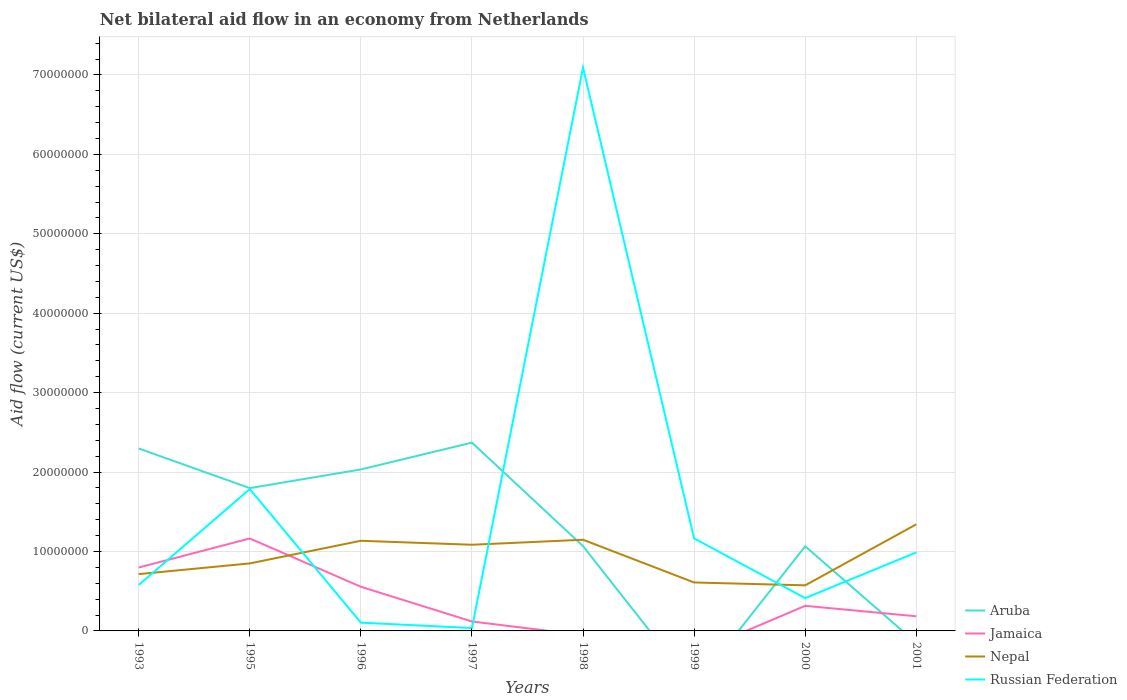What is the total net bilateral aid flow in Nepal in the graph?
Make the answer very short. 3.60e+05. What is the difference between the highest and the second highest net bilateral aid flow in Jamaica?
Your answer should be compact. 1.16e+07. What is the difference between the highest and the lowest net bilateral aid flow in Nepal?
Your response must be concise. 4. How many years are there in the graph?
Provide a succinct answer. 8. What is the difference between two consecutive major ticks on the Y-axis?
Your response must be concise. 1.00e+07. Are the values on the major ticks of Y-axis written in scientific E-notation?
Ensure brevity in your answer.  No. How are the legend labels stacked?
Your answer should be compact. Vertical. What is the title of the graph?
Offer a very short reply. Net bilateral aid flow in an economy from Netherlands. Does "Congo (Republic)" appear as one of the legend labels in the graph?
Offer a terse response. No. What is the Aid flow (current US$) in Aruba in 1993?
Offer a very short reply. 2.30e+07. What is the Aid flow (current US$) of Jamaica in 1993?
Make the answer very short. 7.98e+06. What is the Aid flow (current US$) in Nepal in 1993?
Offer a very short reply. 7.15e+06. What is the Aid flow (current US$) in Russian Federation in 1993?
Your answer should be compact. 5.78e+06. What is the Aid flow (current US$) in Aruba in 1995?
Provide a succinct answer. 1.80e+07. What is the Aid flow (current US$) of Jamaica in 1995?
Provide a succinct answer. 1.16e+07. What is the Aid flow (current US$) in Nepal in 1995?
Make the answer very short. 8.50e+06. What is the Aid flow (current US$) in Russian Federation in 1995?
Your answer should be very brief. 1.79e+07. What is the Aid flow (current US$) of Aruba in 1996?
Offer a very short reply. 2.03e+07. What is the Aid flow (current US$) in Jamaica in 1996?
Make the answer very short. 5.56e+06. What is the Aid flow (current US$) of Nepal in 1996?
Your answer should be compact. 1.14e+07. What is the Aid flow (current US$) of Russian Federation in 1996?
Keep it short and to the point. 1.04e+06. What is the Aid flow (current US$) of Aruba in 1997?
Your response must be concise. 2.37e+07. What is the Aid flow (current US$) in Jamaica in 1997?
Provide a succinct answer. 1.19e+06. What is the Aid flow (current US$) of Nepal in 1997?
Provide a succinct answer. 1.08e+07. What is the Aid flow (current US$) in Russian Federation in 1997?
Make the answer very short. 3.60e+05. What is the Aid flow (current US$) of Aruba in 1998?
Your answer should be compact. 1.07e+07. What is the Aid flow (current US$) of Jamaica in 1998?
Offer a very short reply. 0. What is the Aid flow (current US$) of Nepal in 1998?
Offer a very short reply. 1.15e+07. What is the Aid flow (current US$) of Russian Federation in 1998?
Offer a terse response. 7.09e+07. What is the Aid flow (current US$) of Aruba in 1999?
Your answer should be very brief. 0. What is the Aid flow (current US$) in Jamaica in 1999?
Make the answer very short. 0. What is the Aid flow (current US$) of Nepal in 1999?
Give a very brief answer. 6.10e+06. What is the Aid flow (current US$) in Russian Federation in 1999?
Keep it short and to the point. 1.16e+07. What is the Aid flow (current US$) in Aruba in 2000?
Your answer should be compact. 1.07e+07. What is the Aid flow (current US$) in Jamaica in 2000?
Offer a very short reply. 3.16e+06. What is the Aid flow (current US$) of Nepal in 2000?
Provide a succinct answer. 5.74e+06. What is the Aid flow (current US$) in Russian Federation in 2000?
Provide a succinct answer. 4.13e+06. What is the Aid flow (current US$) of Aruba in 2001?
Give a very brief answer. 0. What is the Aid flow (current US$) in Jamaica in 2001?
Your answer should be very brief. 1.84e+06. What is the Aid flow (current US$) of Nepal in 2001?
Keep it short and to the point. 1.34e+07. What is the Aid flow (current US$) of Russian Federation in 2001?
Your answer should be very brief. 9.88e+06. Across all years, what is the maximum Aid flow (current US$) of Aruba?
Provide a succinct answer. 2.37e+07. Across all years, what is the maximum Aid flow (current US$) in Jamaica?
Keep it short and to the point. 1.16e+07. Across all years, what is the maximum Aid flow (current US$) of Nepal?
Your answer should be compact. 1.34e+07. Across all years, what is the maximum Aid flow (current US$) in Russian Federation?
Your answer should be compact. 7.09e+07. Across all years, what is the minimum Aid flow (current US$) in Jamaica?
Make the answer very short. 0. Across all years, what is the minimum Aid flow (current US$) of Nepal?
Ensure brevity in your answer.  5.74e+06. Across all years, what is the minimum Aid flow (current US$) in Russian Federation?
Make the answer very short. 3.60e+05. What is the total Aid flow (current US$) in Aruba in the graph?
Your response must be concise. 1.06e+08. What is the total Aid flow (current US$) of Jamaica in the graph?
Make the answer very short. 3.14e+07. What is the total Aid flow (current US$) of Nepal in the graph?
Offer a terse response. 7.46e+07. What is the total Aid flow (current US$) in Russian Federation in the graph?
Give a very brief answer. 1.22e+08. What is the difference between the Aid flow (current US$) in Aruba in 1993 and that in 1995?
Your response must be concise. 4.99e+06. What is the difference between the Aid flow (current US$) of Jamaica in 1993 and that in 1995?
Offer a very short reply. -3.66e+06. What is the difference between the Aid flow (current US$) in Nepal in 1993 and that in 1995?
Your response must be concise. -1.35e+06. What is the difference between the Aid flow (current US$) of Russian Federation in 1993 and that in 1995?
Provide a succinct answer. -1.21e+07. What is the difference between the Aid flow (current US$) in Aruba in 1993 and that in 1996?
Your response must be concise. 2.64e+06. What is the difference between the Aid flow (current US$) in Jamaica in 1993 and that in 1996?
Ensure brevity in your answer.  2.42e+06. What is the difference between the Aid flow (current US$) of Nepal in 1993 and that in 1996?
Keep it short and to the point. -4.20e+06. What is the difference between the Aid flow (current US$) in Russian Federation in 1993 and that in 1996?
Your answer should be compact. 4.74e+06. What is the difference between the Aid flow (current US$) in Aruba in 1993 and that in 1997?
Offer a very short reply. -7.40e+05. What is the difference between the Aid flow (current US$) in Jamaica in 1993 and that in 1997?
Provide a short and direct response. 6.79e+06. What is the difference between the Aid flow (current US$) of Nepal in 1993 and that in 1997?
Provide a short and direct response. -3.70e+06. What is the difference between the Aid flow (current US$) of Russian Federation in 1993 and that in 1997?
Offer a terse response. 5.42e+06. What is the difference between the Aid flow (current US$) in Aruba in 1993 and that in 1998?
Ensure brevity in your answer.  1.23e+07. What is the difference between the Aid flow (current US$) of Nepal in 1993 and that in 1998?
Keep it short and to the point. -4.33e+06. What is the difference between the Aid flow (current US$) in Russian Federation in 1993 and that in 1998?
Offer a terse response. -6.52e+07. What is the difference between the Aid flow (current US$) of Nepal in 1993 and that in 1999?
Your answer should be very brief. 1.05e+06. What is the difference between the Aid flow (current US$) in Russian Federation in 1993 and that in 1999?
Ensure brevity in your answer.  -5.87e+06. What is the difference between the Aid flow (current US$) in Aruba in 1993 and that in 2000?
Ensure brevity in your answer.  1.23e+07. What is the difference between the Aid flow (current US$) in Jamaica in 1993 and that in 2000?
Provide a short and direct response. 4.82e+06. What is the difference between the Aid flow (current US$) in Nepal in 1993 and that in 2000?
Ensure brevity in your answer.  1.41e+06. What is the difference between the Aid flow (current US$) in Russian Federation in 1993 and that in 2000?
Offer a terse response. 1.65e+06. What is the difference between the Aid flow (current US$) in Jamaica in 1993 and that in 2001?
Your answer should be compact. 6.14e+06. What is the difference between the Aid flow (current US$) in Nepal in 1993 and that in 2001?
Provide a short and direct response. -6.27e+06. What is the difference between the Aid flow (current US$) in Russian Federation in 1993 and that in 2001?
Make the answer very short. -4.10e+06. What is the difference between the Aid flow (current US$) in Aruba in 1995 and that in 1996?
Give a very brief answer. -2.35e+06. What is the difference between the Aid flow (current US$) in Jamaica in 1995 and that in 1996?
Your response must be concise. 6.08e+06. What is the difference between the Aid flow (current US$) of Nepal in 1995 and that in 1996?
Provide a short and direct response. -2.85e+06. What is the difference between the Aid flow (current US$) of Russian Federation in 1995 and that in 1996?
Provide a short and direct response. 1.68e+07. What is the difference between the Aid flow (current US$) in Aruba in 1995 and that in 1997?
Ensure brevity in your answer.  -5.73e+06. What is the difference between the Aid flow (current US$) in Jamaica in 1995 and that in 1997?
Your answer should be compact. 1.04e+07. What is the difference between the Aid flow (current US$) of Nepal in 1995 and that in 1997?
Your response must be concise. -2.35e+06. What is the difference between the Aid flow (current US$) of Russian Federation in 1995 and that in 1997?
Give a very brief answer. 1.75e+07. What is the difference between the Aid flow (current US$) of Aruba in 1995 and that in 1998?
Make the answer very short. 7.30e+06. What is the difference between the Aid flow (current US$) of Nepal in 1995 and that in 1998?
Your answer should be very brief. -2.98e+06. What is the difference between the Aid flow (current US$) in Russian Federation in 1995 and that in 1998?
Keep it short and to the point. -5.31e+07. What is the difference between the Aid flow (current US$) of Nepal in 1995 and that in 1999?
Your answer should be compact. 2.40e+06. What is the difference between the Aid flow (current US$) in Russian Federation in 1995 and that in 1999?
Keep it short and to the point. 6.21e+06. What is the difference between the Aid flow (current US$) of Aruba in 1995 and that in 2000?
Your answer should be compact. 7.32e+06. What is the difference between the Aid flow (current US$) in Jamaica in 1995 and that in 2000?
Ensure brevity in your answer.  8.48e+06. What is the difference between the Aid flow (current US$) in Nepal in 1995 and that in 2000?
Make the answer very short. 2.76e+06. What is the difference between the Aid flow (current US$) of Russian Federation in 1995 and that in 2000?
Provide a short and direct response. 1.37e+07. What is the difference between the Aid flow (current US$) in Jamaica in 1995 and that in 2001?
Ensure brevity in your answer.  9.80e+06. What is the difference between the Aid flow (current US$) in Nepal in 1995 and that in 2001?
Your response must be concise. -4.92e+06. What is the difference between the Aid flow (current US$) in Russian Federation in 1995 and that in 2001?
Your answer should be very brief. 7.98e+06. What is the difference between the Aid flow (current US$) of Aruba in 1996 and that in 1997?
Provide a succinct answer. -3.38e+06. What is the difference between the Aid flow (current US$) in Jamaica in 1996 and that in 1997?
Your answer should be very brief. 4.37e+06. What is the difference between the Aid flow (current US$) of Russian Federation in 1996 and that in 1997?
Offer a terse response. 6.80e+05. What is the difference between the Aid flow (current US$) of Aruba in 1996 and that in 1998?
Provide a succinct answer. 9.65e+06. What is the difference between the Aid flow (current US$) in Nepal in 1996 and that in 1998?
Offer a terse response. -1.30e+05. What is the difference between the Aid flow (current US$) of Russian Federation in 1996 and that in 1998?
Keep it short and to the point. -6.99e+07. What is the difference between the Aid flow (current US$) of Nepal in 1996 and that in 1999?
Ensure brevity in your answer.  5.25e+06. What is the difference between the Aid flow (current US$) in Russian Federation in 1996 and that in 1999?
Provide a short and direct response. -1.06e+07. What is the difference between the Aid flow (current US$) of Aruba in 1996 and that in 2000?
Your response must be concise. 9.67e+06. What is the difference between the Aid flow (current US$) in Jamaica in 1996 and that in 2000?
Your answer should be compact. 2.40e+06. What is the difference between the Aid flow (current US$) in Nepal in 1996 and that in 2000?
Provide a short and direct response. 5.61e+06. What is the difference between the Aid flow (current US$) in Russian Federation in 1996 and that in 2000?
Keep it short and to the point. -3.09e+06. What is the difference between the Aid flow (current US$) in Jamaica in 1996 and that in 2001?
Give a very brief answer. 3.72e+06. What is the difference between the Aid flow (current US$) in Nepal in 1996 and that in 2001?
Ensure brevity in your answer.  -2.07e+06. What is the difference between the Aid flow (current US$) of Russian Federation in 1996 and that in 2001?
Make the answer very short. -8.84e+06. What is the difference between the Aid flow (current US$) in Aruba in 1997 and that in 1998?
Offer a very short reply. 1.30e+07. What is the difference between the Aid flow (current US$) in Nepal in 1997 and that in 1998?
Ensure brevity in your answer.  -6.30e+05. What is the difference between the Aid flow (current US$) of Russian Federation in 1997 and that in 1998?
Provide a short and direct response. -7.06e+07. What is the difference between the Aid flow (current US$) in Nepal in 1997 and that in 1999?
Provide a short and direct response. 4.75e+06. What is the difference between the Aid flow (current US$) of Russian Federation in 1997 and that in 1999?
Keep it short and to the point. -1.13e+07. What is the difference between the Aid flow (current US$) of Aruba in 1997 and that in 2000?
Give a very brief answer. 1.30e+07. What is the difference between the Aid flow (current US$) of Jamaica in 1997 and that in 2000?
Offer a terse response. -1.97e+06. What is the difference between the Aid flow (current US$) of Nepal in 1997 and that in 2000?
Offer a terse response. 5.11e+06. What is the difference between the Aid flow (current US$) of Russian Federation in 1997 and that in 2000?
Keep it short and to the point. -3.77e+06. What is the difference between the Aid flow (current US$) of Jamaica in 1997 and that in 2001?
Provide a short and direct response. -6.50e+05. What is the difference between the Aid flow (current US$) in Nepal in 1997 and that in 2001?
Make the answer very short. -2.57e+06. What is the difference between the Aid flow (current US$) of Russian Federation in 1997 and that in 2001?
Ensure brevity in your answer.  -9.52e+06. What is the difference between the Aid flow (current US$) of Nepal in 1998 and that in 1999?
Give a very brief answer. 5.38e+06. What is the difference between the Aid flow (current US$) in Russian Federation in 1998 and that in 1999?
Offer a terse response. 5.93e+07. What is the difference between the Aid flow (current US$) in Aruba in 1998 and that in 2000?
Ensure brevity in your answer.  2.00e+04. What is the difference between the Aid flow (current US$) of Nepal in 1998 and that in 2000?
Your answer should be very brief. 5.74e+06. What is the difference between the Aid flow (current US$) in Russian Federation in 1998 and that in 2000?
Ensure brevity in your answer.  6.68e+07. What is the difference between the Aid flow (current US$) in Nepal in 1998 and that in 2001?
Give a very brief answer. -1.94e+06. What is the difference between the Aid flow (current US$) in Russian Federation in 1998 and that in 2001?
Offer a very short reply. 6.10e+07. What is the difference between the Aid flow (current US$) of Nepal in 1999 and that in 2000?
Keep it short and to the point. 3.60e+05. What is the difference between the Aid flow (current US$) of Russian Federation in 1999 and that in 2000?
Your answer should be compact. 7.52e+06. What is the difference between the Aid flow (current US$) in Nepal in 1999 and that in 2001?
Your answer should be very brief. -7.32e+06. What is the difference between the Aid flow (current US$) in Russian Federation in 1999 and that in 2001?
Give a very brief answer. 1.77e+06. What is the difference between the Aid flow (current US$) in Jamaica in 2000 and that in 2001?
Keep it short and to the point. 1.32e+06. What is the difference between the Aid flow (current US$) in Nepal in 2000 and that in 2001?
Offer a very short reply. -7.68e+06. What is the difference between the Aid flow (current US$) in Russian Federation in 2000 and that in 2001?
Provide a short and direct response. -5.75e+06. What is the difference between the Aid flow (current US$) in Aruba in 1993 and the Aid flow (current US$) in Jamaica in 1995?
Your response must be concise. 1.13e+07. What is the difference between the Aid flow (current US$) in Aruba in 1993 and the Aid flow (current US$) in Nepal in 1995?
Provide a short and direct response. 1.45e+07. What is the difference between the Aid flow (current US$) in Aruba in 1993 and the Aid flow (current US$) in Russian Federation in 1995?
Ensure brevity in your answer.  5.11e+06. What is the difference between the Aid flow (current US$) of Jamaica in 1993 and the Aid flow (current US$) of Nepal in 1995?
Offer a very short reply. -5.20e+05. What is the difference between the Aid flow (current US$) in Jamaica in 1993 and the Aid flow (current US$) in Russian Federation in 1995?
Offer a terse response. -9.88e+06. What is the difference between the Aid flow (current US$) in Nepal in 1993 and the Aid flow (current US$) in Russian Federation in 1995?
Ensure brevity in your answer.  -1.07e+07. What is the difference between the Aid flow (current US$) of Aruba in 1993 and the Aid flow (current US$) of Jamaica in 1996?
Offer a terse response. 1.74e+07. What is the difference between the Aid flow (current US$) of Aruba in 1993 and the Aid flow (current US$) of Nepal in 1996?
Your response must be concise. 1.16e+07. What is the difference between the Aid flow (current US$) in Aruba in 1993 and the Aid flow (current US$) in Russian Federation in 1996?
Keep it short and to the point. 2.19e+07. What is the difference between the Aid flow (current US$) in Jamaica in 1993 and the Aid flow (current US$) in Nepal in 1996?
Provide a succinct answer. -3.37e+06. What is the difference between the Aid flow (current US$) in Jamaica in 1993 and the Aid flow (current US$) in Russian Federation in 1996?
Ensure brevity in your answer.  6.94e+06. What is the difference between the Aid flow (current US$) of Nepal in 1993 and the Aid flow (current US$) of Russian Federation in 1996?
Give a very brief answer. 6.11e+06. What is the difference between the Aid flow (current US$) in Aruba in 1993 and the Aid flow (current US$) in Jamaica in 1997?
Provide a short and direct response. 2.18e+07. What is the difference between the Aid flow (current US$) in Aruba in 1993 and the Aid flow (current US$) in Nepal in 1997?
Your answer should be very brief. 1.21e+07. What is the difference between the Aid flow (current US$) of Aruba in 1993 and the Aid flow (current US$) of Russian Federation in 1997?
Your answer should be compact. 2.26e+07. What is the difference between the Aid flow (current US$) in Jamaica in 1993 and the Aid flow (current US$) in Nepal in 1997?
Your response must be concise. -2.87e+06. What is the difference between the Aid flow (current US$) in Jamaica in 1993 and the Aid flow (current US$) in Russian Federation in 1997?
Offer a terse response. 7.62e+06. What is the difference between the Aid flow (current US$) of Nepal in 1993 and the Aid flow (current US$) of Russian Federation in 1997?
Provide a short and direct response. 6.79e+06. What is the difference between the Aid flow (current US$) of Aruba in 1993 and the Aid flow (current US$) of Nepal in 1998?
Provide a short and direct response. 1.15e+07. What is the difference between the Aid flow (current US$) of Aruba in 1993 and the Aid flow (current US$) of Russian Federation in 1998?
Your answer should be compact. -4.80e+07. What is the difference between the Aid flow (current US$) of Jamaica in 1993 and the Aid flow (current US$) of Nepal in 1998?
Provide a short and direct response. -3.50e+06. What is the difference between the Aid flow (current US$) in Jamaica in 1993 and the Aid flow (current US$) in Russian Federation in 1998?
Your response must be concise. -6.30e+07. What is the difference between the Aid flow (current US$) in Nepal in 1993 and the Aid flow (current US$) in Russian Federation in 1998?
Your answer should be very brief. -6.38e+07. What is the difference between the Aid flow (current US$) of Aruba in 1993 and the Aid flow (current US$) of Nepal in 1999?
Your response must be concise. 1.69e+07. What is the difference between the Aid flow (current US$) of Aruba in 1993 and the Aid flow (current US$) of Russian Federation in 1999?
Provide a short and direct response. 1.13e+07. What is the difference between the Aid flow (current US$) of Jamaica in 1993 and the Aid flow (current US$) of Nepal in 1999?
Offer a very short reply. 1.88e+06. What is the difference between the Aid flow (current US$) of Jamaica in 1993 and the Aid flow (current US$) of Russian Federation in 1999?
Keep it short and to the point. -3.67e+06. What is the difference between the Aid flow (current US$) of Nepal in 1993 and the Aid flow (current US$) of Russian Federation in 1999?
Your answer should be compact. -4.50e+06. What is the difference between the Aid flow (current US$) of Aruba in 1993 and the Aid flow (current US$) of Jamaica in 2000?
Provide a short and direct response. 1.98e+07. What is the difference between the Aid flow (current US$) of Aruba in 1993 and the Aid flow (current US$) of Nepal in 2000?
Give a very brief answer. 1.72e+07. What is the difference between the Aid flow (current US$) in Aruba in 1993 and the Aid flow (current US$) in Russian Federation in 2000?
Provide a short and direct response. 1.88e+07. What is the difference between the Aid flow (current US$) in Jamaica in 1993 and the Aid flow (current US$) in Nepal in 2000?
Ensure brevity in your answer.  2.24e+06. What is the difference between the Aid flow (current US$) of Jamaica in 1993 and the Aid flow (current US$) of Russian Federation in 2000?
Provide a short and direct response. 3.85e+06. What is the difference between the Aid flow (current US$) of Nepal in 1993 and the Aid flow (current US$) of Russian Federation in 2000?
Ensure brevity in your answer.  3.02e+06. What is the difference between the Aid flow (current US$) of Aruba in 1993 and the Aid flow (current US$) of Jamaica in 2001?
Offer a terse response. 2.11e+07. What is the difference between the Aid flow (current US$) of Aruba in 1993 and the Aid flow (current US$) of Nepal in 2001?
Your answer should be compact. 9.55e+06. What is the difference between the Aid flow (current US$) of Aruba in 1993 and the Aid flow (current US$) of Russian Federation in 2001?
Offer a terse response. 1.31e+07. What is the difference between the Aid flow (current US$) of Jamaica in 1993 and the Aid flow (current US$) of Nepal in 2001?
Your answer should be compact. -5.44e+06. What is the difference between the Aid flow (current US$) in Jamaica in 1993 and the Aid flow (current US$) in Russian Federation in 2001?
Provide a short and direct response. -1.90e+06. What is the difference between the Aid flow (current US$) of Nepal in 1993 and the Aid flow (current US$) of Russian Federation in 2001?
Provide a short and direct response. -2.73e+06. What is the difference between the Aid flow (current US$) in Aruba in 1995 and the Aid flow (current US$) in Jamaica in 1996?
Keep it short and to the point. 1.24e+07. What is the difference between the Aid flow (current US$) of Aruba in 1995 and the Aid flow (current US$) of Nepal in 1996?
Make the answer very short. 6.63e+06. What is the difference between the Aid flow (current US$) of Aruba in 1995 and the Aid flow (current US$) of Russian Federation in 1996?
Your answer should be compact. 1.69e+07. What is the difference between the Aid flow (current US$) in Jamaica in 1995 and the Aid flow (current US$) in Nepal in 1996?
Keep it short and to the point. 2.90e+05. What is the difference between the Aid flow (current US$) in Jamaica in 1995 and the Aid flow (current US$) in Russian Federation in 1996?
Your response must be concise. 1.06e+07. What is the difference between the Aid flow (current US$) of Nepal in 1995 and the Aid flow (current US$) of Russian Federation in 1996?
Keep it short and to the point. 7.46e+06. What is the difference between the Aid flow (current US$) of Aruba in 1995 and the Aid flow (current US$) of Jamaica in 1997?
Provide a short and direct response. 1.68e+07. What is the difference between the Aid flow (current US$) in Aruba in 1995 and the Aid flow (current US$) in Nepal in 1997?
Your response must be concise. 7.13e+06. What is the difference between the Aid flow (current US$) of Aruba in 1995 and the Aid flow (current US$) of Russian Federation in 1997?
Your answer should be very brief. 1.76e+07. What is the difference between the Aid flow (current US$) in Jamaica in 1995 and the Aid flow (current US$) in Nepal in 1997?
Your response must be concise. 7.90e+05. What is the difference between the Aid flow (current US$) in Jamaica in 1995 and the Aid flow (current US$) in Russian Federation in 1997?
Provide a short and direct response. 1.13e+07. What is the difference between the Aid flow (current US$) of Nepal in 1995 and the Aid flow (current US$) of Russian Federation in 1997?
Provide a short and direct response. 8.14e+06. What is the difference between the Aid flow (current US$) in Aruba in 1995 and the Aid flow (current US$) in Nepal in 1998?
Offer a terse response. 6.50e+06. What is the difference between the Aid flow (current US$) of Aruba in 1995 and the Aid flow (current US$) of Russian Federation in 1998?
Offer a terse response. -5.30e+07. What is the difference between the Aid flow (current US$) of Jamaica in 1995 and the Aid flow (current US$) of Nepal in 1998?
Your answer should be compact. 1.60e+05. What is the difference between the Aid flow (current US$) in Jamaica in 1995 and the Aid flow (current US$) in Russian Federation in 1998?
Make the answer very short. -5.93e+07. What is the difference between the Aid flow (current US$) in Nepal in 1995 and the Aid flow (current US$) in Russian Federation in 1998?
Make the answer very short. -6.24e+07. What is the difference between the Aid flow (current US$) in Aruba in 1995 and the Aid flow (current US$) in Nepal in 1999?
Your answer should be compact. 1.19e+07. What is the difference between the Aid flow (current US$) of Aruba in 1995 and the Aid flow (current US$) of Russian Federation in 1999?
Provide a succinct answer. 6.33e+06. What is the difference between the Aid flow (current US$) in Jamaica in 1995 and the Aid flow (current US$) in Nepal in 1999?
Your answer should be very brief. 5.54e+06. What is the difference between the Aid flow (current US$) of Jamaica in 1995 and the Aid flow (current US$) of Russian Federation in 1999?
Ensure brevity in your answer.  -10000. What is the difference between the Aid flow (current US$) of Nepal in 1995 and the Aid flow (current US$) of Russian Federation in 1999?
Your response must be concise. -3.15e+06. What is the difference between the Aid flow (current US$) of Aruba in 1995 and the Aid flow (current US$) of Jamaica in 2000?
Your answer should be compact. 1.48e+07. What is the difference between the Aid flow (current US$) in Aruba in 1995 and the Aid flow (current US$) in Nepal in 2000?
Your answer should be compact. 1.22e+07. What is the difference between the Aid flow (current US$) in Aruba in 1995 and the Aid flow (current US$) in Russian Federation in 2000?
Provide a succinct answer. 1.38e+07. What is the difference between the Aid flow (current US$) in Jamaica in 1995 and the Aid flow (current US$) in Nepal in 2000?
Provide a succinct answer. 5.90e+06. What is the difference between the Aid flow (current US$) in Jamaica in 1995 and the Aid flow (current US$) in Russian Federation in 2000?
Keep it short and to the point. 7.51e+06. What is the difference between the Aid flow (current US$) in Nepal in 1995 and the Aid flow (current US$) in Russian Federation in 2000?
Your answer should be very brief. 4.37e+06. What is the difference between the Aid flow (current US$) in Aruba in 1995 and the Aid flow (current US$) in Jamaica in 2001?
Your response must be concise. 1.61e+07. What is the difference between the Aid flow (current US$) of Aruba in 1995 and the Aid flow (current US$) of Nepal in 2001?
Offer a very short reply. 4.56e+06. What is the difference between the Aid flow (current US$) of Aruba in 1995 and the Aid flow (current US$) of Russian Federation in 2001?
Provide a short and direct response. 8.10e+06. What is the difference between the Aid flow (current US$) in Jamaica in 1995 and the Aid flow (current US$) in Nepal in 2001?
Keep it short and to the point. -1.78e+06. What is the difference between the Aid flow (current US$) in Jamaica in 1995 and the Aid flow (current US$) in Russian Federation in 2001?
Ensure brevity in your answer.  1.76e+06. What is the difference between the Aid flow (current US$) of Nepal in 1995 and the Aid flow (current US$) of Russian Federation in 2001?
Provide a succinct answer. -1.38e+06. What is the difference between the Aid flow (current US$) of Aruba in 1996 and the Aid flow (current US$) of Jamaica in 1997?
Your answer should be compact. 1.91e+07. What is the difference between the Aid flow (current US$) of Aruba in 1996 and the Aid flow (current US$) of Nepal in 1997?
Provide a succinct answer. 9.48e+06. What is the difference between the Aid flow (current US$) of Aruba in 1996 and the Aid flow (current US$) of Russian Federation in 1997?
Offer a terse response. 2.00e+07. What is the difference between the Aid flow (current US$) of Jamaica in 1996 and the Aid flow (current US$) of Nepal in 1997?
Provide a short and direct response. -5.29e+06. What is the difference between the Aid flow (current US$) of Jamaica in 1996 and the Aid flow (current US$) of Russian Federation in 1997?
Keep it short and to the point. 5.20e+06. What is the difference between the Aid flow (current US$) of Nepal in 1996 and the Aid flow (current US$) of Russian Federation in 1997?
Give a very brief answer. 1.10e+07. What is the difference between the Aid flow (current US$) of Aruba in 1996 and the Aid flow (current US$) of Nepal in 1998?
Make the answer very short. 8.85e+06. What is the difference between the Aid flow (current US$) in Aruba in 1996 and the Aid flow (current US$) in Russian Federation in 1998?
Your answer should be very brief. -5.06e+07. What is the difference between the Aid flow (current US$) in Jamaica in 1996 and the Aid flow (current US$) in Nepal in 1998?
Provide a succinct answer. -5.92e+06. What is the difference between the Aid flow (current US$) in Jamaica in 1996 and the Aid flow (current US$) in Russian Federation in 1998?
Provide a short and direct response. -6.54e+07. What is the difference between the Aid flow (current US$) in Nepal in 1996 and the Aid flow (current US$) in Russian Federation in 1998?
Keep it short and to the point. -5.96e+07. What is the difference between the Aid flow (current US$) in Aruba in 1996 and the Aid flow (current US$) in Nepal in 1999?
Your response must be concise. 1.42e+07. What is the difference between the Aid flow (current US$) of Aruba in 1996 and the Aid flow (current US$) of Russian Federation in 1999?
Your answer should be compact. 8.68e+06. What is the difference between the Aid flow (current US$) in Jamaica in 1996 and the Aid flow (current US$) in Nepal in 1999?
Provide a succinct answer. -5.40e+05. What is the difference between the Aid flow (current US$) in Jamaica in 1996 and the Aid flow (current US$) in Russian Federation in 1999?
Offer a terse response. -6.09e+06. What is the difference between the Aid flow (current US$) in Nepal in 1996 and the Aid flow (current US$) in Russian Federation in 1999?
Offer a terse response. -3.00e+05. What is the difference between the Aid flow (current US$) of Aruba in 1996 and the Aid flow (current US$) of Jamaica in 2000?
Offer a terse response. 1.72e+07. What is the difference between the Aid flow (current US$) of Aruba in 1996 and the Aid flow (current US$) of Nepal in 2000?
Give a very brief answer. 1.46e+07. What is the difference between the Aid flow (current US$) in Aruba in 1996 and the Aid flow (current US$) in Russian Federation in 2000?
Offer a terse response. 1.62e+07. What is the difference between the Aid flow (current US$) of Jamaica in 1996 and the Aid flow (current US$) of Nepal in 2000?
Offer a terse response. -1.80e+05. What is the difference between the Aid flow (current US$) in Jamaica in 1996 and the Aid flow (current US$) in Russian Federation in 2000?
Make the answer very short. 1.43e+06. What is the difference between the Aid flow (current US$) of Nepal in 1996 and the Aid flow (current US$) of Russian Federation in 2000?
Give a very brief answer. 7.22e+06. What is the difference between the Aid flow (current US$) of Aruba in 1996 and the Aid flow (current US$) of Jamaica in 2001?
Offer a terse response. 1.85e+07. What is the difference between the Aid flow (current US$) of Aruba in 1996 and the Aid flow (current US$) of Nepal in 2001?
Your answer should be compact. 6.91e+06. What is the difference between the Aid flow (current US$) of Aruba in 1996 and the Aid flow (current US$) of Russian Federation in 2001?
Offer a very short reply. 1.04e+07. What is the difference between the Aid flow (current US$) of Jamaica in 1996 and the Aid flow (current US$) of Nepal in 2001?
Your response must be concise. -7.86e+06. What is the difference between the Aid flow (current US$) in Jamaica in 1996 and the Aid flow (current US$) in Russian Federation in 2001?
Make the answer very short. -4.32e+06. What is the difference between the Aid flow (current US$) in Nepal in 1996 and the Aid flow (current US$) in Russian Federation in 2001?
Offer a terse response. 1.47e+06. What is the difference between the Aid flow (current US$) of Aruba in 1997 and the Aid flow (current US$) of Nepal in 1998?
Keep it short and to the point. 1.22e+07. What is the difference between the Aid flow (current US$) in Aruba in 1997 and the Aid flow (current US$) in Russian Federation in 1998?
Offer a terse response. -4.72e+07. What is the difference between the Aid flow (current US$) of Jamaica in 1997 and the Aid flow (current US$) of Nepal in 1998?
Give a very brief answer. -1.03e+07. What is the difference between the Aid flow (current US$) in Jamaica in 1997 and the Aid flow (current US$) in Russian Federation in 1998?
Your response must be concise. -6.97e+07. What is the difference between the Aid flow (current US$) of Nepal in 1997 and the Aid flow (current US$) of Russian Federation in 1998?
Provide a short and direct response. -6.01e+07. What is the difference between the Aid flow (current US$) of Aruba in 1997 and the Aid flow (current US$) of Nepal in 1999?
Your answer should be very brief. 1.76e+07. What is the difference between the Aid flow (current US$) in Aruba in 1997 and the Aid flow (current US$) in Russian Federation in 1999?
Your answer should be very brief. 1.21e+07. What is the difference between the Aid flow (current US$) of Jamaica in 1997 and the Aid flow (current US$) of Nepal in 1999?
Give a very brief answer. -4.91e+06. What is the difference between the Aid flow (current US$) in Jamaica in 1997 and the Aid flow (current US$) in Russian Federation in 1999?
Offer a very short reply. -1.05e+07. What is the difference between the Aid flow (current US$) in Nepal in 1997 and the Aid flow (current US$) in Russian Federation in 1999?
Provide a short and direct response. -8.00e+05. What is the difference between the Aid flow (current US$) of Aruba in 1997 and the Aid flow (current US$) of Jamaica in 2000?
Your answer should be compact. 2.06e+07. What is the difference between the Aid flow (current US$) in Aruba in 1997 and the Aid flow (current US$) in Nepal in 2000?
Provide a short and direct response. 1.80e+07. What is the difference between the Aid flow (current US$) in Aruba in 1997 and the Aid flow (current US$) in Russian Federation in 2000?
Give a very brief answer. 1.96e+07. What is the difference between the Aid flow (current US$) of Jamaica in 1997 and the Aid flow (current US$) of Nepal in 2000?
Offer a very short reply. -4.55e+06. What is the difference between the Aid flow (current US$) of Jamaica in 1997 and the Aid flow (current US$) of Russian Federation in 2000?
Give a very brief answer. -2.94e+06. What is the difference between the Aid flow (current US$) in Nepal in 1997 and the Aid flow (current US$) in Russian Federation in 2000?
Offer a terse response. 6.72e+06. What is the difference between the Aid flow (current US$) of Aruba in 1997 and the Aid flow (current US$) of Jamaica in 2001?
Your answer should be very brief. 2.19e+07. What is the difference between the Aid flow (current US$) in Aruba in 1997 and the Aid flow (current US$) in Nepal in 2001?
Ensure brevity in your answer.  1.03e+07. What is the difference between the Aid flow (current US$) of Aruba in 1997 and the Aid flow (current US$) of Russian Federation in 2001?
Your answer should be compact. 1.38e+07. What is the difference between the Aid flow (current US$) of Jamaica in 1997 and the Aid flow (current US$) of Nepal in 2001?
Offer a very short reply. -1.22e+07. What is the difference between the Aid flow (current US$) in Jamaica in 1997 and the Aid flow (current US$) in Russian Federation in 2001?
Give a very brief answer. -8.69e+06. What is the difference between the Aid flow (current US$) in Nepal in 1997 and the Aid flow (current US$) in Russian Federation in 2001?
Offer a very short reply. 9.70e+05. What is the difference between the Aid flow (current US$) of Aruba in 1998 and the Aid flow (current US$) of Nepal in 1999?
Provide a succinct answer. 4.58e+06. What is the difference between the Aid flow (current US$) in Aruba in 1998 and the Aid flow (current US$) in Russian Federation in 1999?
Offer a terse response. -9.70e+05. What is the difference between the Aid flow (current US$) of Nepal in 1998 and the Aid flow (current US$) of Russian Federation in 1999?
Provide a succinct answer. -1.70e+05. What is the difference between the Aid flow (current US$) in Aruba in 1998 and the Aid flow (current US$) in Jamaica in 2000?
Offer a terse response. 7.52e+06. What is the difference between the Aid flow (current US$) of Aruba in 1998 and the Aid flow (current US$) of Nepal in 2000?
Provide a succinct answer. 4.94e+06. What is the difference between the Aid flow (current US$) in Aruba in 1998 and the Aid flow (current US$) in Russian Federation in 2000?
Offer a terse response. 6.55e+06. What is the difference between the Aid flow (current US$) of Nepal in 1998 and the Aid flow (current US$) of Russian Federation in 2000?
Offer a very short reply. 7.35e+06. What is the difference between the Aid flow (current US$) of Aruba in 1998 and the Aid flow (current US$) of Jamaica in 2001?
Your answer should be compact. 8.84e+06. What is the difference between the Aid flow (current US$) in Aruba in 1998 and the Aid flow (current US$) in Nepal in 2001?
Your response must be concise. -2.74e+06. What is the difference between the Aid flow (current US$) of Nepal in 1998 and the Aid flow (current US$) of Russian Federation in 2001?
Ensure brevity in your answer.  1.60e+06. What is the difference between the Aid flow (current US$) of Nepal in 1999 and the Aid flow (current US$) of Russian Federation in 2000?
Make the answer very short. 1.97e+06. What is the difference between the Aid flow (current US$) of Nepal in 1999 and the Aid flow (current US$) of Russian Federation in 2001?
Your response must be concise. -3.78e+06. What is the difference between the Aid flow (current US$) in Aruba in 2000 and the Aid flow (current US$) in Jamaica in 2001?
Make the answer very short. 8.82e+06. What is the difference between the Aid flow (current US$) in Aruba in 2000 and the Aid flow (current US$) in Nepal in 2001?
Provide a short and direct response. -2.76e+06. What is the difference between the Aid flow (current US$) of Aruba in 2000 and the Aid flow (current US$) of Russian Federation in 2001?
Ensure brevity in your answer.  7.80e+05. What is the difference between the Aid flow (current US$) of Jamaica in 2000 and the Aid flow (current US$) of Nepal in 2001?
Give a very brief answer. -1.03e+07. What is the difference between the Aid flow (current US$) in Jamaica in 2000 and the Aid flow (current US$) in Russian Federation in 2001?
Your response must be concise. -6.72e+06. What is the difference between the Aid flow (current US$) of Nepal in 2000 and the Aid flow (current US$) of Russian Federation in 2001?
Your response must be concise. -4.14e+06. What is the average Aid flow (current US$) in Aruba per year?
Your answer should be compact. 1.33e+07. What is the average Aid flow (current US$) of Jamaica per year?
Make the answer very short. 3.92e+06. What is the average Aid flow (current US$) of Nepal per year?
Your answer should be very brief. 9.32e+06. What is the average Aid flow (current US$) in Russian Federation per year?
Give a very brief answer. 1.52e+07. In the year 1993, what is the difference between the Aid flow (current US$) of Aruba and Aid flow (current US$) of Jamaica?
Give a very brief answer. 1.50e+07. In the year 1993, what is the difference between the Aid flow (current US$) in Aruba and Aid flow (current US$) in Nepal?
Give a very brief answer. 1.58e+07. In the year 1993, what is the difference between the Aid flow (current US$) of Aruba and Aid flow (current US$) of Russian Federation?
Your answer should be compact. 1.72e+07. In the year 1993, what is the difference between the Aid flow (current US$) in Jamaica and Aid flow (current US$) in Nepal?
Provide a succinct answer. 8.30e+05. In the year 1993, what is the difference between the Aid flow (current US$) of Jamaica and Aid flow (current US$) of Russian Federation?
Keep it short and to the point. 2.20e+06. In the year 1993, what is the difference between the Aid flow (current US$) of Nepal and Aid flow (current US$) of Russian Federation?
Give a very brief answer. 1.37e+06. In the year 1995, what is the difference between the Aid flow (current US$) of Aruba and Aid flow (current US$) of Jamaica?
Give a very brief answer. 6.34e+06. In the year 1995, what is the difference between the Aid flow (current US$) of Aruba and Aid flow (current US$) of Nepal?
Make the answer very short. 9.48e+06. In the year 1995, what is the difference between the Aid flow (current US$) in Aruba and Aid flow (current US$) in Russian Federation?
Your answer should be very brief. 1.20e+05. In the year 1995, what is the difference between the Aid flow (current US$) in Jamaica and Aid flow (current US$) in Nepal?
Give a very brief answer. 3.14e+06. In the year 1995, what is the difference between the Aid flow (current US$) of Jamaica and Aid flow (current US$) of Russian Federation?
Offer a very short reply. -6.22e+06. In the year 1995, what is the difference between the Aid flow (current US$) in Nepal and Aid flow (current US$) in Russian Federation?
Ensure brevity in your answer.  -9.36e+06. In the year 1996, what is the difference between the Aid flow (current US$) of Aruba and Aid flow (current US$) of Jamaica?
Provide a short and direct response. 1.48e+07. In the year 1996, what is the difference between the Aid flow (current US$) of Aruba and Aid flow (current US$) of Nepal?
Your answer should be compact. 8.98e+06. In the year 1996, what is the difference between the Aid flow (current US$) of Aruba and Aid flow (current US$) of Russian Federation?
Ensure brevity in your answer.  1.93e+07. In the year 1996, what is the difference between the Aid flow (current US$) in Jamaica and Aid flow (current US$) in Nepal?
Your response must be concise. -5.79e+06. In the year 1996, what is the difference between the Aid flow (current US$) in Jamaica and Aid flow (current US$) in Russian Federation?
Offer a terse response. 4.52e+06. In the year 1996, what is the difference between the Aid flow (current US$) of Nepal and Aid flow (current US$) of Russian Federation?
Make the answer very short. 1.03e+07. In the year 1997, what is the difference between the Aid flow (current US$) in Aruba and Aid flow (current US$) in Jamaica?
Provide a short and direct response. 2.25e+07. In the year 1997, what is the difference between the Aid flow (current US$) in Aruba and Aid flow (current US$) in Nepal?
Ensure brevity in your answer.  1.29e+07. In the year 1997, what is the difference between the Aid flow (current US$) of Aruba and Aid flow (current US$) of Russian Federation?
Your answer should be very brief. 2.34e+07. In the year 1997, what is the difference between the Aid flow (current US$) in Jamaica and Aid flow (current US$) in Nepal?
Ensure brevity in your answer.  -9.66e+06. In the year 1997, what is the difference between the Aid flow (current US$) of Jamaica and Aid flow (current US$) of Russian Federation?
Offer a very short reply. 8.30e+05. In the year 1997, what is the difference between the Aid flow (current US$) in Nepal and Aid flow (current US$) in Russian Federation?
Keep it short and to the point. 1.05e+07. In the year 1998, what is the difference between the Aid flow (current US$) of Aruba and Aid flow (current US$) of Nepal?
Provide a short and direct response. -8.00e+05. In the year 1998, what is the difference between the Aid flow (current US$) in Aruba and Aid flow (current US$) in Russian Federation?
Ensure brevity in your answer.  -6.02e+07. In the year 1998, what is the difference between the Aid flow (current US$) of Nepal and Aid flow (current US$) of Russian Federation?
Provide a succinct answer. -5.94e+07. In the year 1999, what is the difference between the Aid flow (current US$) of Nepal and Aid flow (current US$) of Russian Federation?
Provide a succinct answer. -5.55e+06. In the year 2000, what is the difference between the Aid flow (current US$) in Aruba and Aid flow (current US$) in Jamaica?
Ensure brevity in your answer.  7.50e+06. In the year 2000, what is the difference between the Aid flow (current US$) in Aruba and Aid flow (current US$) in Nepal?
Offer a very short reply. 4.92e+06. In the year 2000, what is the difference between the Aid flow (current US$) in Aruba and Aid flow (current US$) in Russian Federation?
Offer a terse response. 6.53e+06. In the year 2000, what is the difference between the Aid flow (current US$) in Jamaica and Aid flow (current US$) in Nepal?
Your response must be concise. -2.58e+06. In the year 2000, what is the difference between the Aid flow (current US$) in Jamaica and Aid flow (current US$) in Russian Federation?
Keep it short and to the point. -9.70e+05. In the year 2000, what is the difference between the Aid flow (current US$) of Nepal and Aid flow (current US$) of Russian Federation?
Your answer should be very brief. 1.61e+06. In the year 2001, what is the difference between the Aid flow (current US$) in Jamaica and Aid flow (current US$) in Nepal?
Your response must be concise. -1.16e+07. In the year 2001, what is the difference between the Aid flow (current US$) of Jamaica and Aid flow (current US$) of Russian Federation?
Provide a succinct answer. -8.04e+06. In the year 2001, what is the difference between the Aid flow (current US$) of Nepal and Aid flow (current US$) of Russian Federation?
Your answer should be compact. 3.54e+06. What is the ratio of the Aid flow (current US$) in Aruba in 1993 to that in 1995?
Your answer should be compact. 1.28. What is the ratio of the Aid flow (current US$) of Jamaica in 1993 to that in 1995?
Ensure brevity in your answer.  0.69. What is the ratio of the Aid flow (current US$) of Nepal in 1993 to that in 1995?
Keep it short and to the point. 0.84. What is the ratio of the Aid flow (current US$) in Russian Federation in 1993 to that in 1995?
Provide a succinct answer. 0.32. What is the ratio of the Aid flow (current US$) in Aruba in 1993 to that in 1996?
Provide a short and direct response. 1.13. What is the ratio of the Aid flow (current US$) in Jamaica in 1993 to that in 1996?
Offer a terse response. 1.44. What is the ratio of the Aid flow (current US$) in Nepal in 1993 to that in 1996?
Your answer should be very brief. 0.63. What is the ratio of the Aid flow (current US$) of Russian Federation in 1993 to that in 1996?
Your answer should be very brief. 5.56. What is the ratio of the Aid flow (current US$) of Aruba in 1993 to that in 1997?
Ensure brevity in your answer.  0.97. What is the ratio of the Aid flow (current US$) of Jamaica in 1993 to that in 1997?
Keep it short and to the point. 6.71. What is the ratio of the Aid flow (current US$) in Nepal in 1993 to that in 1997?
Make the answer very short. 0.66. What is the ratio of the Aid flow (current US$) in Russian Federation in 1993 to that in 1997?
Ensure brevity in your answer.  16.06. What is the ratio of the Aid flow (current US$) in Aruba in 1993 to that in 1998?
Provide a succinct answer. 2.15. What is the ratio of the Aid flow (current US$) in Nepal in 1993 to that in 1998?
Your answer should be very brief. 0.62. What is the ratio of the Aid flow (current US$) of Russian Federation in 1993 to that in 1998?
Make the answer very short. 0.08. What is the ratio of the Aid flow (current US$) in Nepal in 1993 to that in 1999?
Your response must be concise. 1.17. What is the ratio of the Aid flow (current US$) in Russian Federation in 1993 to that in 1999?
Your answer should be very brief. 0.5. What is the ratio of the Aid flow (current US$) in Aruba in 1993 to that in 2000?
Offer a terse response. 2.15. What is the ratio of the Aid flow (current US$) of Jamaica in 1993 to that in 2000?
Keep it short and to the point. 2.53. What is the ratio of the Aid flow (current US$) in Nepal in 1993 to that in 2000?
Offer a terse response. 1.25. What is the ratio of the Aid flow (current US$) of Russian Federation in 1993 to that in 2000?
Your answer should be very brief. 1.4. What is the ratio of the Aid flow (current US$) of Jamaica in 1993 to that in 2001?
Keep it short and to the point. 4.34. What is the ratio of the Aid flow (current US$) in Nepal in 1993 to that in 2001?
Your answer should be very brief. 0.53. What is the ratio of the Aid flow (current US$) in Russian Federation in 1993 to that in 2001?
Provide a short and direct response. 0.58. What is the ratio of the Aid flow (current US$) in Aruba in 1995 to that in 1996?
Provide a short and direct response. 0.88. What is the ratio of the Aid flow (current US$) of Jamaica in 1995 to that in 1996?
Offer a very short reply. 2.09. What is the ratio of the Aid flow (current US$) of Nepal in 1995 to that in 1996?
Your answer should be very brief. 0.75. What is the ratio of the Aid flow (current US$) in Russian Federation in 1995 to that in 1996?
Keep it short and to the point. 17.17. What is the ratio of the Aid flow (current US$) in Aruba in 1995 to that in 1997?
Provide a succinct answer. 0.76. What is the ratio of the Aid flow (current US$) in Jamaica in 1995 to that in 1997?
Offer a terse response. 9.78. What is the ratio of the Aid flow (current US$) of Nepal in 1995 to that in 1997?
Your answer should be compact. 0.78. What is the ratio of the Aid flow (current US$) in Russian Federation in 1995 to that in 1997?
Provide a short and direct response. 49.61. What is the ratio of the Aid flow (current US$) of Aruba in 1995 to that in 1998?
Your answer should be very brief. 1.68. What is the ratio of the Aid flow (current US$) in Nepal in 1995 to that in 1998?
Provide a short and direct response. 0.74. What is the ratio of the Aid flow (current US$) in Russian Federation in 1995 to that in 1998?
Your response must be concise. 0.25. What is the ratio of the Aid flow (current US$) of Nepal in 1995 to that in 1999?
Provide a succinct answer. 1.39. What is the ratio of the Aid flow (current US$) in Russian Federation in 1995 to that in 1999?
Your answer should be compact. 1.53. What is the ratio of the Aid flow (current US$) in Aruba in 1995 to that in 2000?
Offer a very short reply. 1.69. What is the ratio of the Aid flow (current US$) in Jamaica in 1995 to that in 2000?
Offer a very short reply. 3.68. What is the ratio of the Aid flow (current US$) in Nepal in 1995 to that in 2000?
Provide a short and direct response. 1.48. What is the ratio of the Aid flow (current US$) of Russian Federation in 1995 to that in 2000?
Offer a terse response. 4.32. What is the ratio of the Aid flow (current US$) in Jamaica in 1995 to that in 2001?
Give a very brief answer. 6.33. What is the ratio of the Aid flow (current US$) in Nepal in 1995 to that in 2001?
Keep it short and to the point. 0.63. What is the ratio of the Aid flow (current US$) of Russian Federation in 1995 to that in 2001?
Provide a short and direct response. 1.81. What is the ratio of the Aid flow (current US$) of Aruba in 1996 to that in 1997?
Your response must be concise. 0.86. What is the ratio of the Aid flow (current US$) of Jamaica in 1996 to that in 1997?
Offer a terse response. 4.67. What is the ratio of the Aid flow (current US$) in Nepal in 1996 to that in 1997?
Give a very brief answer. 1.05. What is the ratio of the Aid flow (current US$) of Russian Federation in 1996 to that in 1997?
Give a very brief answer. 2.89. What is the ratio of the Aid flow (current US$) of Aruba in 1996 to that in 1998?
Your response must be concise. 1.9. What is the ratio of the Aid flow (current US$) in Nepal in 1996 to that in 1998?
Offer a very short reply. 0.99. What is the ratio of the Aid flow (current US$) in Russian Federation in 1996 to that in 1998?
Provide a short and direct response. 0.01. What is the ratio of the Aid flow (current US$) of Nepal in 1996 to that in 1999?
Make the answer very short. 1.86. What is the ratio of the Aid flow (current US$) of Russian Federation in 1996 to that in 1999?
Provide a succinct answer. 0.09. What is the ratio of the Aid flow (current US$) in Aruba in 1996 to that in 2000?
Offer a terse response. 1.91. What is the ratio of the Aid flow (current US$) of Jamaica in 1996 to that in 2000?
Your answer should be compact. 1.76. What is the ratio of the Aid flow (current US$) of Nepal in 1996 to that in 2000?
Provide a short and direct response. 1.98. What is the ratio of the Aid flow (current US$) in Russian Federation in 1996 to that in 2000?
Your answer should be very brief. 0.25. What is the ratio of the Aid flow (current US$) in Jamaica in 1996 to that in 2001?
Provide a succinct answer. 3.02. What is the ratio of the Aid flow (current US$) of Nepal in 1996 to that in 2001?
Your answer should be very brief. 0.85. What is the ratio of the Aid flow (current US$) in Russian Federation in 1996 to that in 2001?
Offer a terse response. 0.11. What is the ratio of the Aid flow (current US$) in Aruba in 1997 to that in 1998?
Make the answer very short. 2.22. What is the ratio of the Aid flow (current US$) in Nepal in 1997 to that in 1998?
Keep it short and to the point. 0.95. What is the ratio of the Aid flow (current US$) in Russian Federation in 1997 to that in 1998?
Make the answer very short. 0.01. What is the ratio of the Aid flow (current US$) of Nepal in 1997 to that in 1999?
Provide a succinct answer. 1.78. What is the ratio of the Aid flow (current US$) in Russian Federation in 1997 to that in 1999?
Provide a short and direct response. 0.03. What is the ratio of the Aid flow (current US$) in Aruba in 1997 to that in 2000?
Your answer should be very brief. 2.22. What is the ratio of the Aid flow (current US$) of Jamaica in 1997 to that in 2000?
Offer a very short reply. 0.38. What is the ratio of the Aid flow (current US$) in Nepal in 1997 to that in 2000?
Offer a terse response. 1.89. What is the ratio of the Aid flow (current US$) in Russian Federation in 1997 to that in 2000?
Offer a terse response. 0.09. What is the ratio of the Aid flow (current US$) in Jamaica in 1997 to that in 2001?
Your answer should be compact. 0.65. What is the ratio of the Aid flow (current US$) in Nepal in 1997 to that in 2001?
Provide a short and direct response. 0.81. What is the ratio of the Aid flow (current US$) of Russian Federation in 1997 to that in 2001?
Provide a short and direct response. 0.04. What is the ratio of the Aid flow (current US$) in Nepal in 1998 to that in 1999?
Provide a short and direct response. 1.88. What is the ratio of the Aid flow (current US$) of Russian Federation in 1998 to that in 1999?
Make the answer very short. 6.09. What is the ratio of the Aid flow (current US$) in Aruba in 1998 to that in 2000?
Provide a succinct answer. 1. What is the ratio of the Aid flow (current US$) in Nepal in 1998 to that in 2000?
Keep it short and to the point. 2. What is the ratio of the Aid flow (current US$) in Russian Federation in 1998 to that in 2000?
Provide a succinct answer. 17.17. What is the ratio of the Aid flow (current US$) of Nepal in 1998 to that in 2001?
Provide a short and direct response. 0.86. What is the ratio of the Aid flow (current US$) in Russian Federation in 1998 to that in 2001?
Provide a short and direct response. 7.18. What is the ratio of the Aid flow (current US$) in Nepal in 1999 to that in 2000?
Your answer should be very brief. 1.06. What is the ratio of the Aid flow (current US$) in Russian Federation in 1999 to that in 2000?
Offer a terse response. 2.82. What is the ratio of the Aid flow (current US$) in Nepal in 1999 to that in 2001?
Provide a succinct answer. 0.45. What is the ratio of the Aid flow (current US$) in Russian Federation in 1999 to that in 2001?
Provide a short and direct response. 1.18. What is the ratio of the Aid flow (current US$) of Jamaica in 2000 to that in 2001?
Give a very brief answer. 1.72. What is the ratio of the Aid flow (current US$) of Nepal in 2000 to that in 2001?
Provide a succinct answer. 0.43. What is the ratio of the Aid flow (current US$) of Russian Federation in 2000 to that in 2001?
Provide a short and direct response. 0.42. What is the difference between the highest and the second highest Aid flow (current US$) in Aruba?
Provide a short and direct response. 7.40e+05. What is the difference between the highest and the second highest Aid flow (current US$) in Jamaica?
Keep it short and to the point. 3.66e+06. What is the difference between the highest and the second highest Aid flow (current US$) in Nepal?
Your response must be concise. 1.94e+06. What is the difference between the highest and the second highest Aid flow (current US$) in Russian Federation?
Ensure brevity in your answer.  5.31e+07. What is the difference between the highest and the lowest Aid flow (current US$) of Aruba?
Your response must be concise. 2.37e+07. What is the difference between the highest and the lowest Aid flow (current US$) of Jamaica?
Give a very brief answer. 1.16e+07. What is the difference between the highest and the lowest Aid flow (current US$) of Nepal?
Offer a terse response. 7.68e+06. What is the difference between the highest and the lowest Aid flow (current US$) in Russian Federation?
Keep it short and to the point. 7.06e+07. 